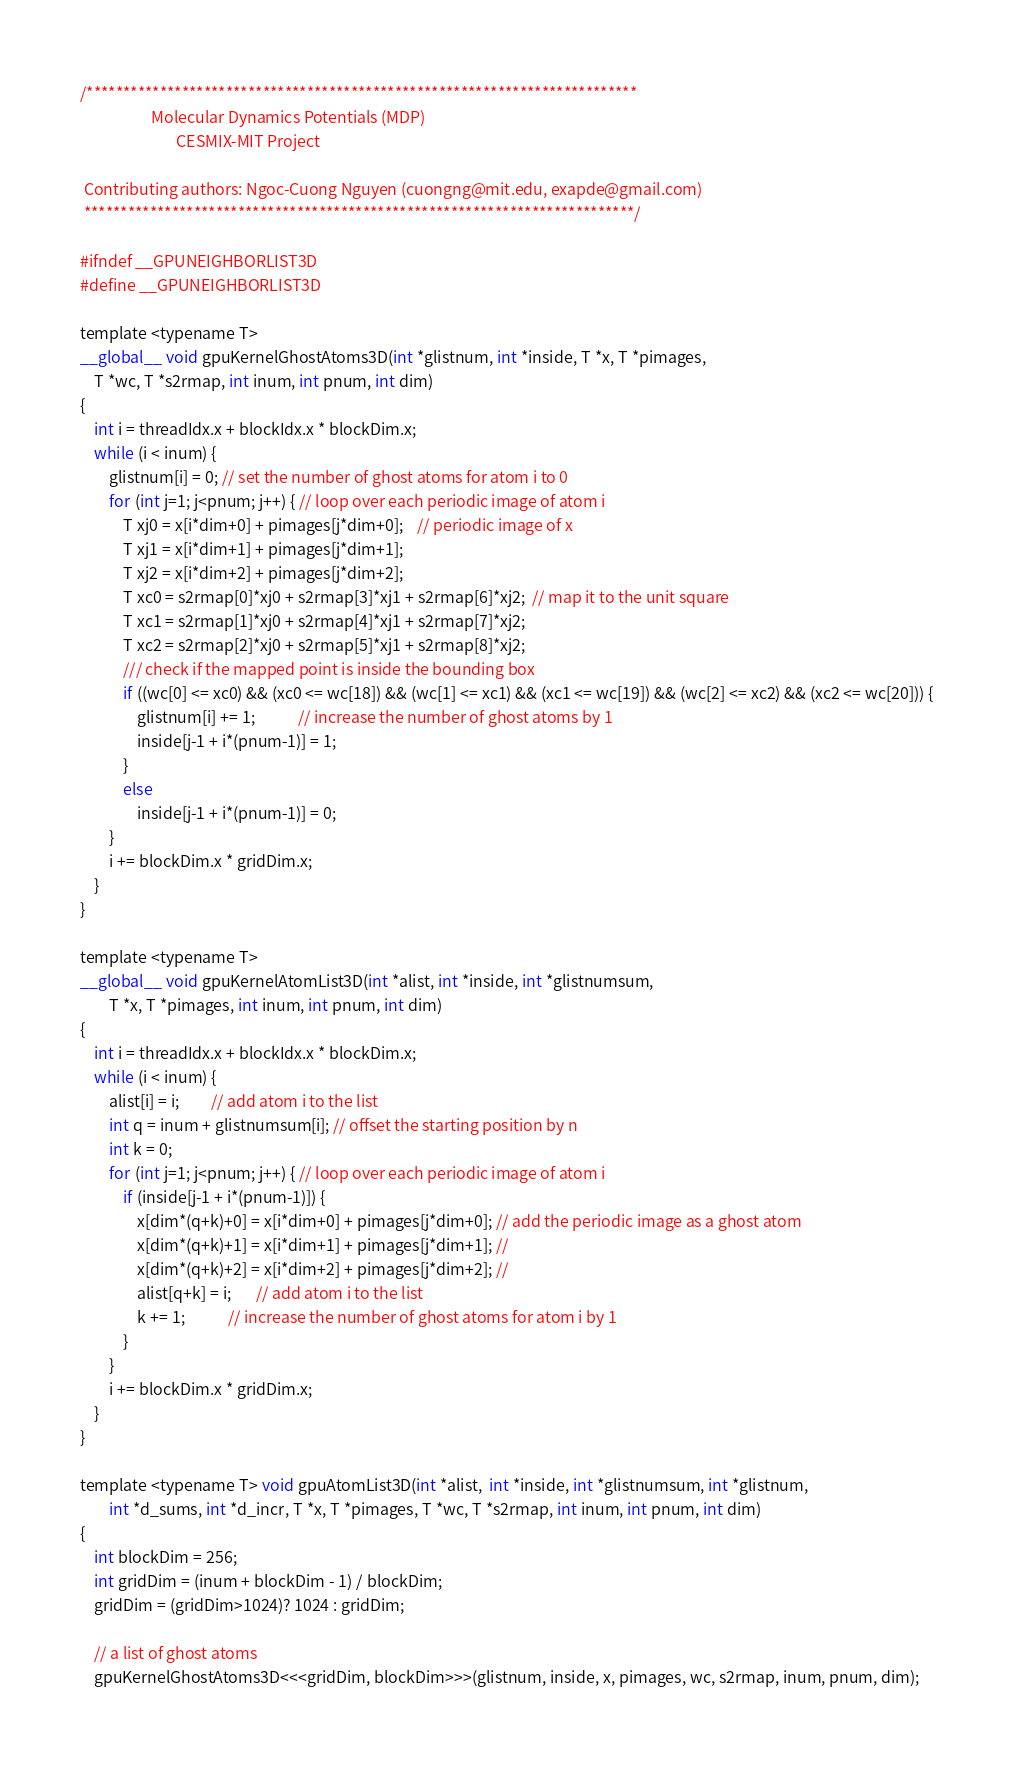<code> <loc_0><loc_0><loc_500><loc_500><_Cuda_>/***************************************************************************                               
                    Molecular Dynamics Potentials (MDP)
                           CESMIX-MIT Project  
 
 Contributing authors: Ngoc-Cuong Nguyen (cuongng@mit.edu, exapde@gmail.com)
 ***************************************************************************/

#ifndef __GPUNEIGHBORLIST3D
#define __GPUNEIGHBORLIST3D

template <typename T>
__global__ void gpuKernelGhostAtoms3D(int *glistnum, int *inside, T *x, T *pimages, 
    T *wc, T *s2rmap, int inum, int pnum, int dim)
{
    int i = threadIdx.x + blockIdx.x * blockDim.x;
    while (i < inum) {
        glistnum[i] = 0; // set the number of ghost atoms for atom i to 0
        for (int j=1; j<pnum; j++) { // loop over each periodic image of atom i
            T xj0 = x[i*dim+0] + pimages[j*dim+0];    // periodic image of x          
            T xj1 = x[i*dim+1] + pimages[j*dim+1];        
            T xj2 = x[i*dim+2] + pimages[j*dim+2];        
            T xc0 = s2rmap[0]*xj0 + s2rmap[3]*xj1 + s2rmap[6]*xj2;  // map it to the unit square            
            T xc1 = s2rmap[1]*xj0 + s2rmap[4]*xj1 + s2rmap[7]*xj2;        
            T xc2 = s2rmap[2]*xj0 + s2rmap[5]*xj1 + s2rmap[8]*xj2;   
            /// check if the mapped point is inside the bounding box
            if ((wc[0] <= xc0) && (xc0 <= wc[18]) && (wc[1] <= xc1) && (xc1 <= wc[19]) && (wc[2] <= xc2) && (xc2 <= wc[20])) {
                glistnum[i] += 1;            // increase the number of ghost atoms by 1                      
                inside[j-1 + i*(pnum-1)] = 1;   
            }
            else
                inside[j-1 + i*(pnum-1)] = 0;
        }        
        i += blockDim.x * gridDim.x;
    }
}

template <typename T>
__global__ void gpuKernelAtomList3D(int *alist, int *inside, int *glistnumsum, 
        T *x, T *pimages, int inum, int pnum, int dim)
{
    int i = threadIdx.x + blockIdx.x * blockDim.x;
    while (i < inum) {
        alist[i] = i;         // add atom i to the list
        int q = inum + glistnumsum[i]; // offset the starting position by n
        int k = 0;            
        for (int j=1; j<pnum; j++) { // loop over each periodic image of atom i
            if (inside[j-1 + i*(pnum-1)]) {      
                x[dim*(q+k)+0] = x[i*dim+0] + pimages[j*dim+0]; // add the periodic image as a ghost atom
                x[dim*(q+k)+1] = x[i*dim+1] + pimages[j*dim+1]; //
                x[dim*(q+k)+2] = x[i*dim+2] + pimages[j*dim+2]; //                
                alist[q+k] = i;       // add atom i to the list
                k += 1;            // increase the number of ghost atoms for atom i by 1    
            }
        }        
        i += blockDim.x * gridDim.x;
    }
}

template <typename T> void gpuAtomList3D(int *alist,  int *inside, int *glistnumsum, int *glistnum, 
        int *d_sums, int *d_incr, T *x, T *pimages, T *wc, T *s2rmap, int inum, int pnum, int dim)
{                        
    int blockDim = 256;
    int gridDim = (inum + blockDim - 1) / blockDim;
    gridDim = (gridDim>1024)? 1024 : gridDim;
    
    // a list of ghost atoms
    gpuKernelGhostAtoms3D<<<gridDim, blockDim>>>(glistnum, inside, x, pimages, wc, s2rmap, inum, pnum, dim);
    </code> 